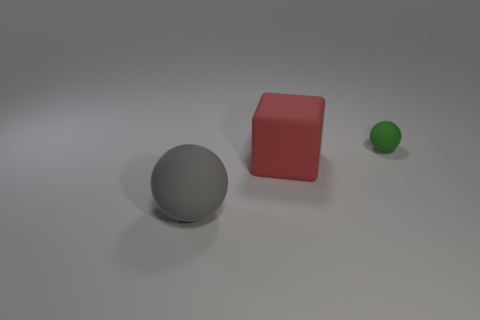What material is the thing that is the same size as the red cube?
Provide a succinct answer. Rubber. Are there fewer large gray balls to the left of the gray matte thing than big gray objects behind the small object?
Ensure brevity in your answer.  No. What shape is the big thing that is behind the matte ball in front of the red block?
Your answer should be very brief. Cube. Are any large green metallic balls visible?
Your response must be concise. No. What color is the thing that is to the left of the big rubber cube?
Give a very brief answer. Gray. There is a green rubber thing; are there any tiny objects on the left side of it?
Offer a terse response. No. Are there more tiny purple cubes than big spheres?
Your answer should be very brief. No. There is a ball behind the matte ball to the left of the matte sphere that is behind the large gray matte ball; what color is it?
Give a very brief answer. Green. What color is the other big thing that is made of the same material as the large red thing?
Provide a succinct answer. Gray. Is there anything else that is the same size as the matte block?
Your answer should be very brief. Yes. 